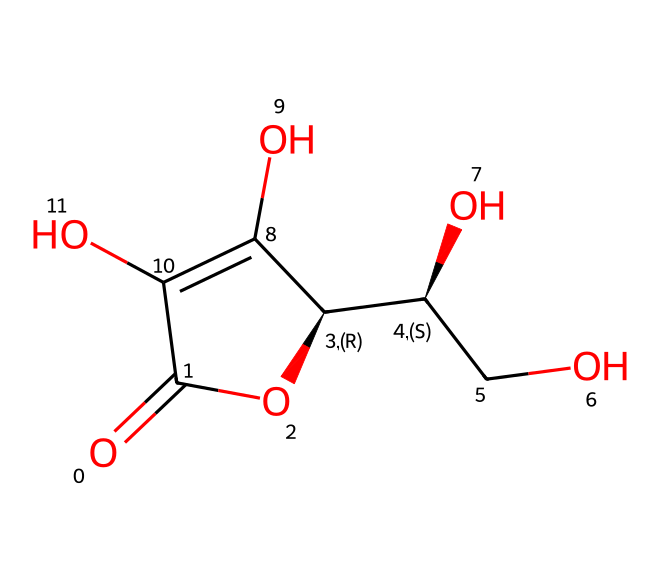What is the molecular formula of vitamin C? To determine the molecular formula, we need to count all the carbon (C), hydrogen (H), and oxygen (O) atoms in the given structure. The SMILES notation reveals that there are 6 carbon atoms, 8 hydrogen atoms, and 6 oxygen atoms. Therefore, the molecular formula is C6H8O6.
Answer: C6H8O6 How many chiral centers does this molecule have? A chiral center is typically a carbon atom that has four different substituents. By analyzing the structure via the SMILES, we can identify two carbon atoms that have four different groups attached, indicating that there are two chiral centers present in this molecule.
Answer: 2 What is the significance of vitamin C being an antioxidant? An antioxidant neutralizes free radicals, thus preventing cellular damage. Examining the structure, the presence of hydroxy groups (-OH) allows this molecule to donate electrons, aiding in this protective function.
Answer: neutralizes free radicals Which bonds in this molecule indicate it can donate electrons? The hydroxyl groups (-OH) in the structure are responsible for the electron donation capabilities of this molecule. Each -OH group can participate in the reduction of free radicals, confirming the antioxidant properties of vitamin C.
Answer: hydroxyl groups How does the structure of vitamin C contribute to its solubility in water? The molecular structure contains multiple -OH groups that can form hydrogen bonds with water molecules, significantly contributing to its high solubility in aqueous environments. Assessing the molecule, the polar character from these hydroxyl groups allows this compound to dissolve well in water.
Answer: hydrogen bonds What is the role of vitamin C in preserving vintage audio tapes? Vitamin C acts as a reducing agent that protects the tapes from oxidation, thereby enhancing their longevity. Analyzing the chemical structure, its antioxidant properties help to mitigate degradation that could impair the tapes, leading to better preservation.
Answer: reducing agent 